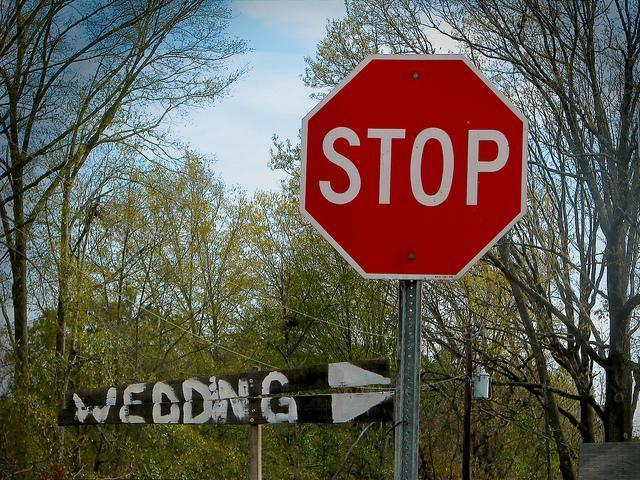How many signs are there?
Give a very brief answer. 2. 